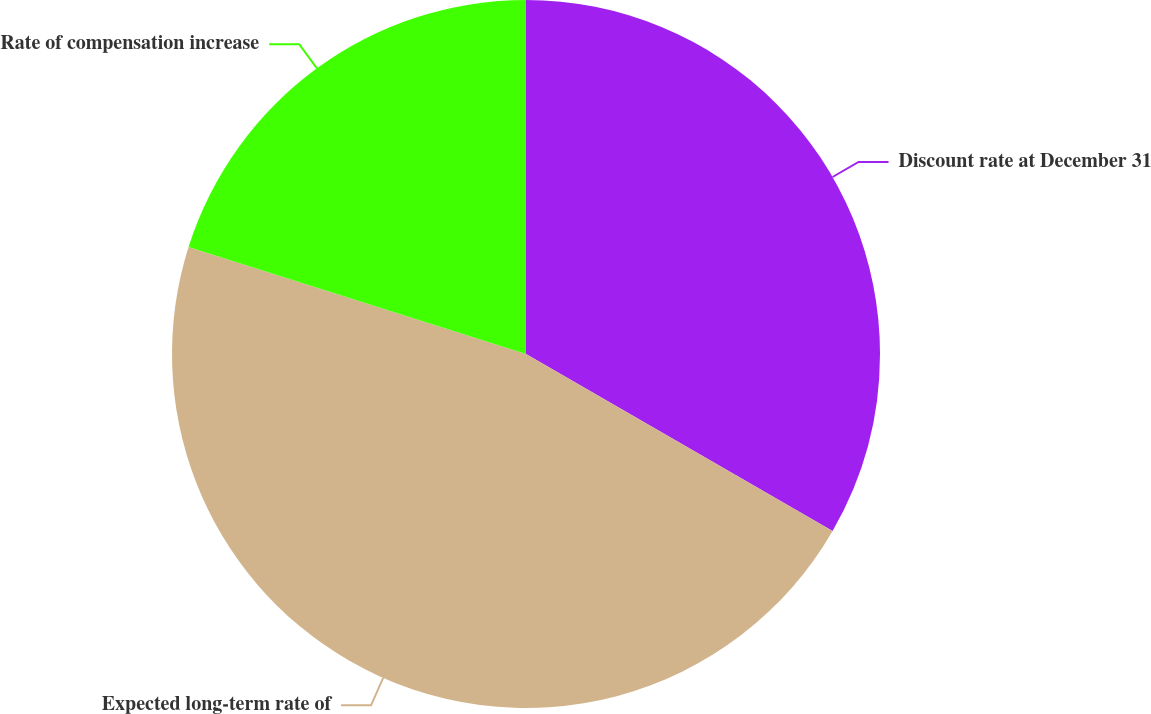<chart> <loc_0><loc_0><loc_500><loc_500><pie_chart><fcel>Discount rate at December 31<fcel>Expected long-term rate of<fcel>Rate of compensation increase<nl><fcel>33.33%<fcel>46.55%<fcel>20.11%<nl></chart> 